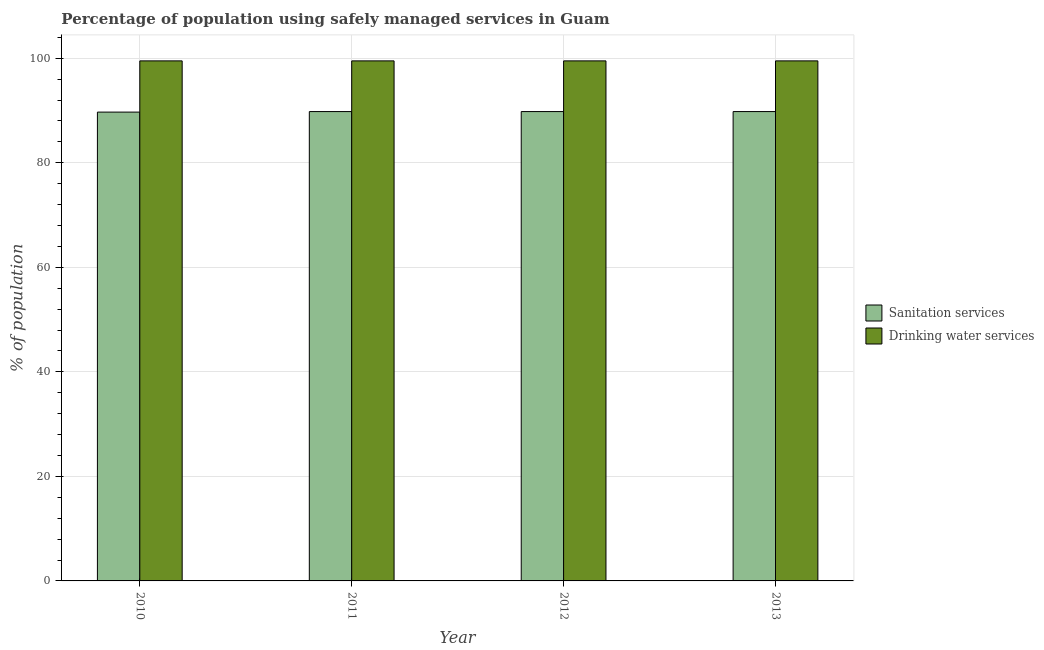How many different coloured bars are there?
Offer a very short reply. 2. How many bars are there on the 1st tick from the left?
Make the answer very short. 2. What is the label of the 2nd group of bars from the left?
Provide a succinct answer. 2011. What is the percentage of population who used sanitation services in 2013?
Provide a short and direct response. 89.8. Across all years, what is the maximum percentage of population who used drinking water services?
Offer a terse response. 99.5. Across all years, what is the minimum percentage of population who used drinking water services?
Provide a short and direct response. 99.5. In which year was the percentage of population who used sanitation services minimum?
Make the answer very short. 2010. What is the total percentage of population who used drinking water services in the graph?
Give a very brief answer. 398. What is the difference between the percentage of population who used sanitation services in 2011 and that in 2013?
Provide a short and direct response. 0. What is the difference between the percentage of population who used drinking water services in 2013 and the percentage of population who used sanitation services in 2012?
Give a very brief answer. 0. What is the average percentage of population who used sanitation services per year?
Ensure brevity in your answer.  89.78. What is the ratio of the percentage of population who used drinking water services in 2011 to that in 2012?
Offer a terse response. 1. Is the difference between the percentage of population who used drinking water services in 2010 and 2013 greater than the difference between the percentage of population who used sanitation services in 2010 and 2013?
Ensure brevity in your answer.  No. What is the difference between the highest and the lowest percentage of population who used sanitation services?
Keep it short and to the point. 0.1. Is the sum of the percentage of population who used sanitation services in 2010 and 2012 greater than the maximum percentage of population who used drinking water services across all years?
Keep it short and to the point. Yes. What does the 1st bar from the left in 2011 represents?
Your answer should be very brief. Sanitation services. What does the 1st bar from the right in 2013 represents?
Your response must be concise. Drinking water services. How many bars are there?
Your answer should be compact. 8. Are all the bars in the graph horizontal?
Your response must be concise. No. How many years are there in the graph?
Ensure brevity in your answer.  4. What is the difference between two consecutive major ticks on the Y-axis?
Keep it short and to the point. 20. Are the values on the major ticks of Y-axis written in scientific E-notation?
Offer a terse response. No. Where does the legend appear in the graph?
Provide a succinct answer. Center right. How are the legend labels stacked?
Your answer should be very brief. Vertical. What is the title of the graph?
Make the answer very short. Percentage of population using safely managed services in Guam. What is the label or title of the X-axis?
Offer a very short reply. Year. What is the label or title of the Y-axis?
Make the answer very short. % of population. What is the % of population in Sanitation services in 2010?
Your answer should be compact. 89.7. What is the % of population in Drinking water services in 2010?
Offer a very short reply. 99.5. What is the % of population of Sanitation services in 2011?
Your response must be concise. 89.8. What is the % of population of Drinking water services in 2011?
Your answer should be compact. 99.5. What is the % of population in Sanitation services in 2012?
Keep it short and to the point. 89.8. What is the % of population of Drinking water services in 2012?
Give a very brief answer. 99.5. What is the % of population in Sanitation services in 2013?
Give a very brief answer. 89.8. What is the % of population of Drinking water services in 2013?
Ensure brevity in your answer.  99.5. Across all years, what is the maximum % of population of Sanitation services?
Make the answer very short. 89.8. Across all years, what is the maximum % of population of Drinking water services?
Your answer should be compact. 99.5. Across all years, what is the minimum % of population in Sanitation services?
Provide a short and direct response. 89.7. Across all years, what is the minimum % of population in Drinking water services?
Provide a succinct answer. 99.5. What is the total % of population in Sanitation services in the graph?
Ensure brevity in your answer.  359.1. What is the total % of population in Drinking water services in the graph?
Offer a very short reply. 398. What is the difference between the % of population in Sanitation services in 2010 and that in 2012?
Give a very brief answer. -0.1. What is the difference between the % of population in Drinking water services in 2010 and that in 2012?
Give a very brief answer. 0. What is the difference between the % of population in Sanitation services in 2010 and that in 2013?
Ensure brevity in your answer.  -0.1. What is the difference between the % of population of Drinking water services in 2011 and that in 2013?
Provide a short and direct response. 0. What is the difference between the % of population in Sanitation services in 2010 and the % of population in Drinking water services in 2013?
Offer a very short reply. -9.8. What is the average % of population of Sanitation services per year?
Make the answer very short. 89.78. What is the average % of population in Drinking water services per year?
Your answer should be very brief. 99.5. In the year 2011, what is the difference between the % of population of Sanitation services and % of population of Drinking water services?
Give a very brief answer. -9.7. In the year 2012, what is the difference between the % of population in Sanitation services and % of population in Drinking water services?
Your answer should be very brief. -9.7. What is the ratio of the % of population of Sanitation services in 2010 to that in 2011?
Your answer should be very brief. 1. What is the ratio of the % of population in Sanitation services in 2010 to that in 2013?
Offer a terse response. 1. What is the ratio of the % of population of Drinking water services in 2011 to that in 2012?
Provide a succinct answer. 1. What is the ratio of the % of population in Sanitation services in 2011 to that in 2013?
Give a very brief answer. 1. What is the ratio of the % of population in Drinking water services in 2011 to that in 2013?
Offer a very short reply. 1. What is the ratio of the % of population in Drinking water services in 2012 to that in 2013?
Offer a terse response. 1. What is the difference between the highest and the second highest % of population of Sanitation services?
Make the answer very short. 0. What is the difference between the highest and the second highest % of population of Drinking water services?
Offer a very short reply. 0. What is the difference between the highest and the lowest % of population of Sanitation services?
Your response must be concise. 0.1. What is the difference between the highest and the lowest % of population of Drinking water services?
Provide a short and direct response. 0. 